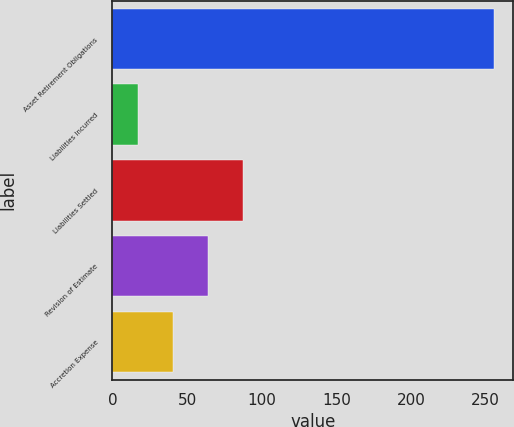Convert chart to OTSL. <chart><loc_0><loc_0><loc_500><loc_500><bar_chart><fcel>Asset Retirement Obligations<fcel>Liabilities Incurred<fcel>Liabilities Settled<fcel>Revision of Estimate<fcel>Accretion Expense<nl><fcel>255.6<fcel>17<fcel>87.8<fcel>64.2<fcel>40.6<nl></chart> 